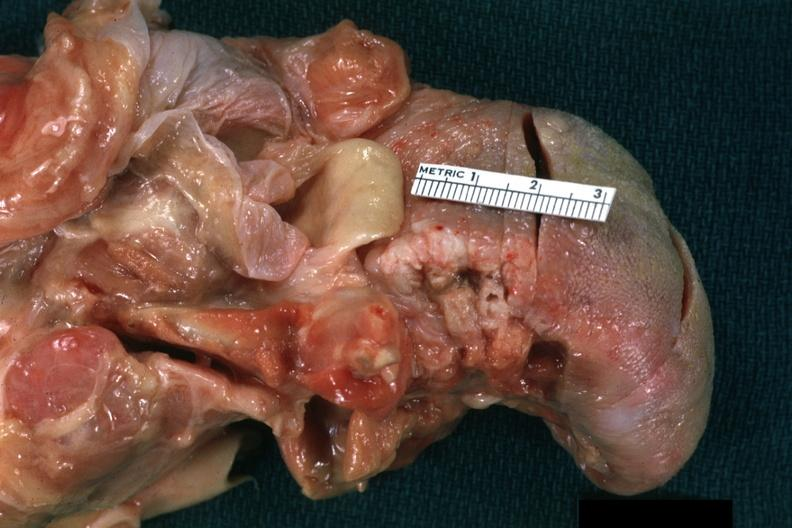does this image show view of ulcerative lesion at base of tongue laterally quite good?
Answer the question using a single word or phrase. Yes 